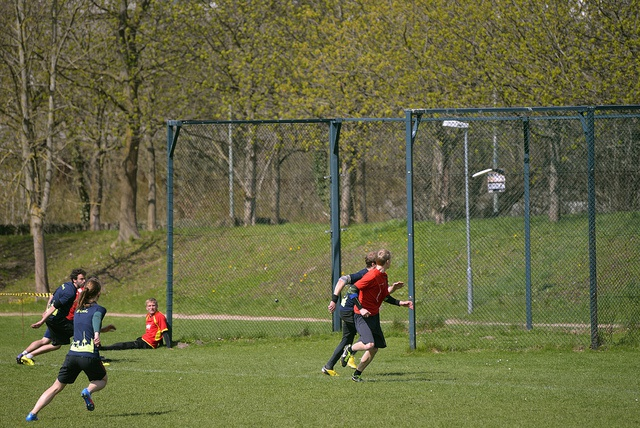Describe the objects in this image and their specific colors. I can see people in gray, black, darkgreen, and darkblue tones, people in gray, black, maroon, and darkgreen tones, people in gray, black, olive, and navy tones, people in gray, black, navy, and darkgreen tones, and people in gray, black, red, salmon, and olive tones in this image. 